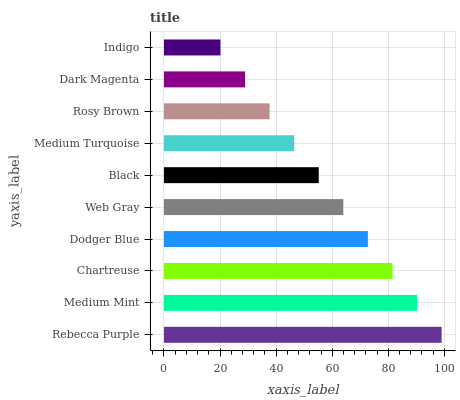Is Indigo the minimum?
Answer yes or no. Yes. Is Rebecca Purple the maximum?
Answer yes or no. Yes. Is Medium Mint the minimum?
Answer yes or no. No. Is Medium Mint the maximum?
Answer yes or no. No. Is Rebecca Purple greater than Medium Mint?
Answer yes or no. Yes. Is Medium Mint less than Rebecca Purple?
Answer yes or no. Yes. Is Medium Mint greater than Rebecca Purple?
Answer yes or no. No. Is Rebecca Purple less than Medium Mint?
Answer yes or no. No. Is Web Gray the high median?
Answer yes or no. Yes. Is Black the low median?
Answer yes or no. Yes. Is Medium Turquoise the high median?
Answer yes or no. No. Is Dodger Blue the low median?
Answer yes or no. No. 